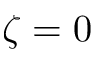Convert formula to latex. <formula><loc_0><loc_0><loc_500><loc_500>\zeta = 0</formula> 